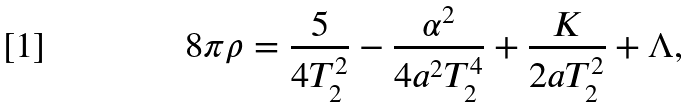Convert formula to latex. <formula><loc_0><loc_0><loc_500><loc_500>8 \pi \rho = \frac { 5 } { 4 T ^ { 2 } _ { 2 } } - \frac { \alpha ^ { 2 } } { 4 a ^ { 2 } T ^ { 4 } _ { 2 } } + \frac { K } { 2 a T ^ { 2 } _ { 2 } } + \Lambda ,</formula> 